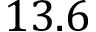<formula> <loc_0><loc_0><loc_500><loc_500>1 3 . 6</formula> 